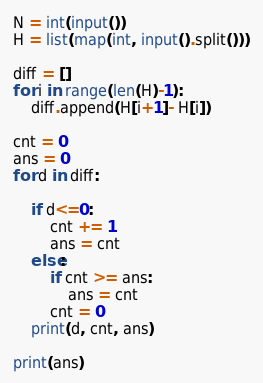Convert code to text. <code><loc_0><loc_0><loc_500><loc_500><_Python_>N = int(input())
H = list(map(int, input().split()))

diff = []
for i in range(len(H)-1):
    diff.append(H[i+1]- H[i])

cnt = 0
ans = 0
for d in diff:
    
    if d<=0:
        cnt += 1
        ans = cnt
    else:
        if cnt >= ans:
            ans = cnt
        cnt = 0
    print(d, cnt, ans)
        
print(ans)</code> 